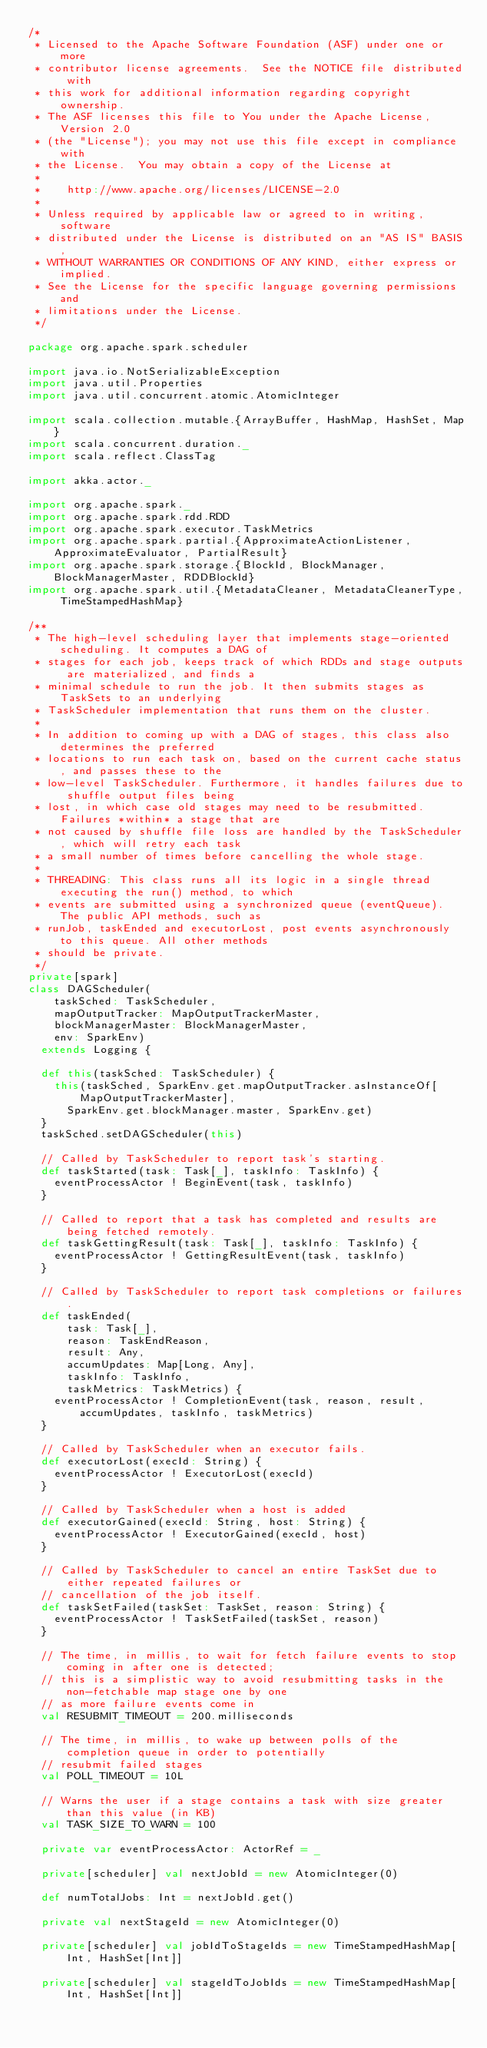Convert code to text. <code><loc_0><loc_0><loc_500><loc_500><_Scala_>/*
 * Licensed to the Apache Software Foundation (ASF) under one or more
 * contributor license agreements.  See the NOTICE file distributed with
 * this work for additional information regarding copyright ownership.
 * The ASF licenses this file to You under the Apache License, Version 2.0
 * (the "License"); you may not use this file except in compliance with
 * the License.  You may obtain a copy of the License at
 *
 *    http://www.apache.org/licenses/LICENSE-2.0
 *
 * Unless required by applicable law or agreed to in writing, software
 * distributed under the License is distributed on an "AS IS" BASIS,
 * WITHOUT WARRANTIES OR CONDITIONS OF ANY KIND, either express or implied.
 * See the License for the specific language governing permissions and
 * limitations under the License.
 */

package org.apache.spark.scheduler

import java.io.NotSerializableException
import java.util.Properties
import java.util.concurrent.atomic.AtomicInteger

import scala.collection.mutable.{ArrayBuffer, HashMap, HashSet, Map}
import scala.concurrent.duration._
import scala.reflect.ClassTag

import akka.actor._

import org.apache.spark._
import org.apache.spark.rdd.RDD
import org.apache.spark.executor.TaskMetrics
import org.apache.spark.partial.{ApproximateActionListener, ApproximateEvaluator, PartialResult}
import org.apache.spark.storage.{BlockId, BlockManager, BlockManagerMaster, RDDBlockId}
import org.apache.spark.util.{MetadataCleaner, MetadataCleanerType, TimeStampedHashMap}

/**
 * The high-level scheduling layer that implements stage-oriented scheduling. It computes a DAG of
 * stages for each job, keeps track of which RDDs and stage outputs are materialized, and finds a
 * minimal schedule to run the job. It then submits stages as TaskSets to an underlying
 * TaskScheduler implementation that runs them on the cluster.
 *
 * In addition to coming up with a DAG of stages, this class also determines the preferred
 * locations to run each task on, based on the current cache status, and passes these to the
 * low-level TaskScheduler. Furthermore, it handles failures due to shuffle output files being
 * lost, in which case old stages may need to be resubmitted. Failures *within* a stage that are
 * not caused by shuffle file loss are handled by the TaskScheduler, which will retry each task
 * a small number of times before cancelling the whole stage.
 *
 * THREADING: This class runs all its logic in a single thread executing the run() method, to which
 * events are submitted using a synchronized queue (eventQueue). The public API methods, such as
 * runJob, taskEnded and executorLost, post events asynchronously to this queue. All other methods
 * should be private.
 */
private[spark]
class DAGScheduler(
    taskSched: TaskScheduler,
    mapOutputTracker: MapOutputTrackerMaster,
    blockManagerMaster: BlockManagerMaster,
    env: SparkEnv)
  extends Logging {

  def this(taskSched: TaskScheduler) {
    this(taskSched, SparkEnv.get.mapOutputTracker.asInstanceOf[MapOutputTrackerMaster],
      SparkEnv.get.blockManager.master, SparkEnv.get)
  }
  taskSched.setDAGScheduler(this)

  // Called by TaskScheduler to report task's starting.
  def taskStarted(task: Task[_], taskInfo: TaskInfo) {
    eventProcessActor ! BeginEvent(task, taskInfo)
  }

  // Called to report that a task has completed and results are being fetched remotely.
  def taskGettingResult(task: Task[_], taskInfo: TaskInfo) {
    eventProcessActor ! GettingResultEvent(task, taskInfo)
  }

  // Called by TaskScheduler to report task completions or failures.
  def taskEnded(
      task: Task[_],
      reason: TaskEndReason,
      result: Any,
      accumUpdates: Map[Long, Any],
      taskInfo: TaskInfo,
      taskMetrics: TaskMetrics) {
    eventProcessActor ! CompletionEvent(task, reason, result, accumUpdates, taskInfo, taskMetrics)
  }

  // Called by TaskScheduler when an executor fails.
  def executorLost(execId: String) {
    eventProcessActor ! ExecutorLost(execId)
  }

  // Called by TaskScheduler when a host is added
  def executorGained(execId: String, host: String) {
    eventProcessActor ! ExecutorGained(execId, host)
  }

  // Called by TaskScheduler to cancel an entire TaskSet due to either repeated failures or
  // cancellation of the job itself.
  def taskSetFailed(taskSet: TaskSet, reason: String) {
    eventProcessActor ! TaskSetFailed(taskSet, reason)
  }

  // The time, in millis, to wait for fetch failure events to stop coming in after one is detected;
  // this is a simplistic way to avoid resubmitting tasks in the non-fetchable map stage one by one
  // as more failure events come in
  val RESUBMIT_TIMEOUT = 200.milliseconds

  // The time, in millis, to wake up between polls of the completion queue in order to potentially
  // resubmit failed stages
  val POLL_TIMEOUT = 10L

  // Warns the user if a stage contains a task with size greater than this value (in KB)
  val TASK_SIZE_TO_WARN = 100

  private var eventProcessActor: ActorRef = _

  private[scheduler] val nextJobId = new AtomicInteger(0)

  def numTotalJobs: Int = nextJobId.get()

  private val nextStageId = new AtomicInteger(0)

  private[scheduler] val jobIdToStageIds = new TimeStampedHashMap[Int, HashSet[Int]]

  private[scheduler] val stageIdToJobIds = new TimeStampedHashMap[Int, HashSet[Int]]
</code> 